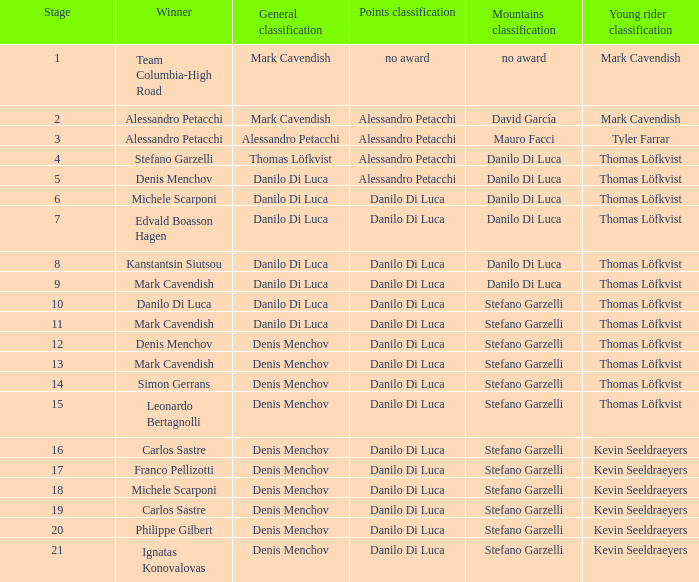In the general classification, who emerges as the winner when it includes thomas löfkvist? Stefano Garzelli. 